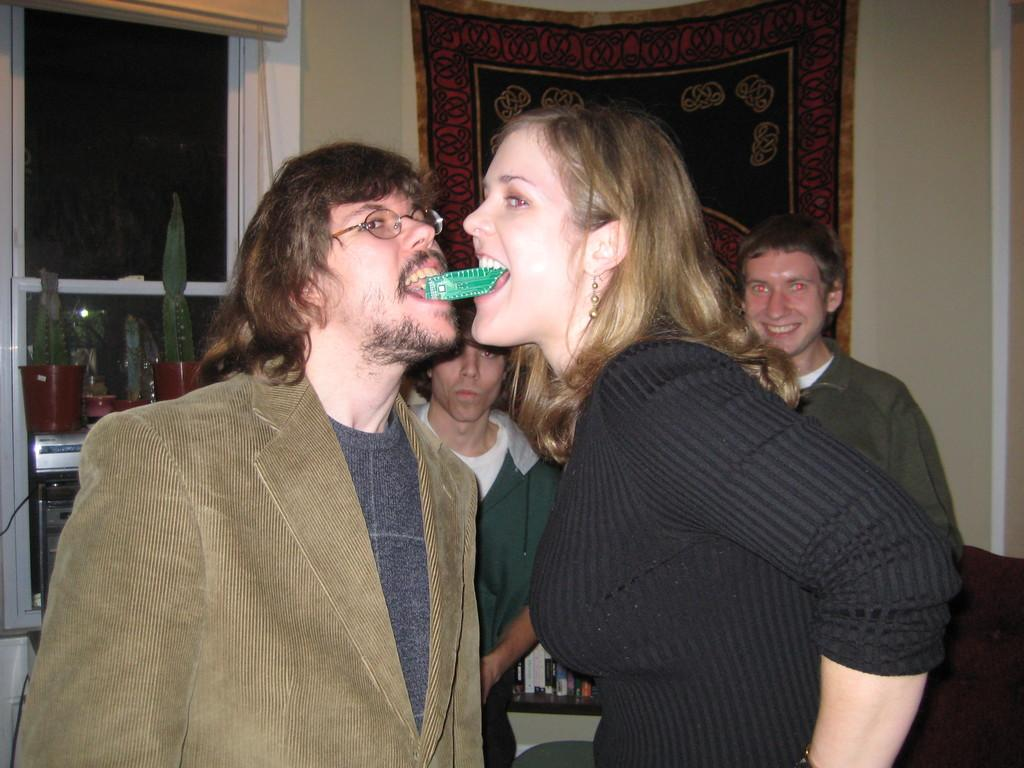What are the two people in the foreground of the image doing? The two people are holding green objects in their mouths. Can you describe the people in the background of the image? There are people in the background of the image, but their actions or appearance are not specified in the provided facts. What type of architectural feature is visible in the image? There is a glass window visible in the image. What type of string is being used by the people in the image? There is no mention of string in the image, so it cannot be determined what type of string, if any, is being used. 